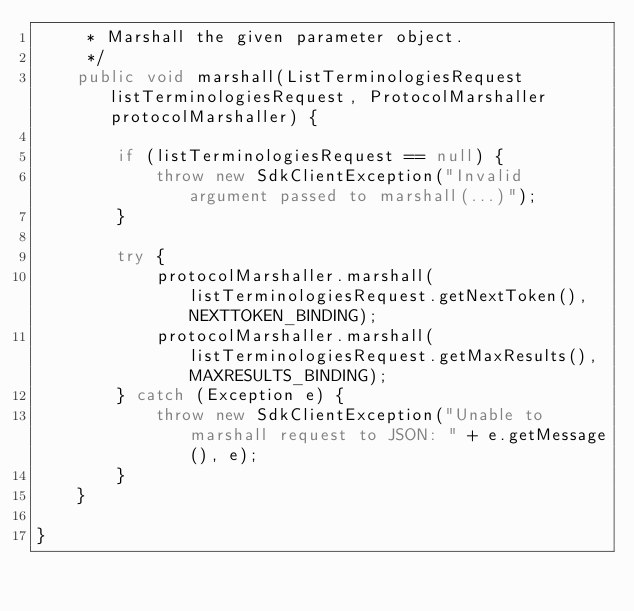<code> <loc_0><loc_0><loc_500><loc_500><_Java_>     * Marshall the given parameter object.
     */
    public void marshall(ListTerminologiesRequest listTerminologiesRequest, ProtocolMarshaller protocolMarshaller) {

        if (listTerminologiesRequest == null) {
            throw new SdkClientException("Invalid argument passed to marshall(...)");
        }

        try {
            protocolMarshaller.marshall(listTerminologiesRequest.getNextToken(), NEXTTOKEN_BINDING);
            protocolMarshaller.marshall(listTerminologiesRequest.getMaxResults(), MAXRESULTS_BINDING);
        } catch (Exception e) {
            throw new SdkClientException("Unable to marshall request to JSON: " + e.getMessage(), e);
        }
    }

}
</code> 